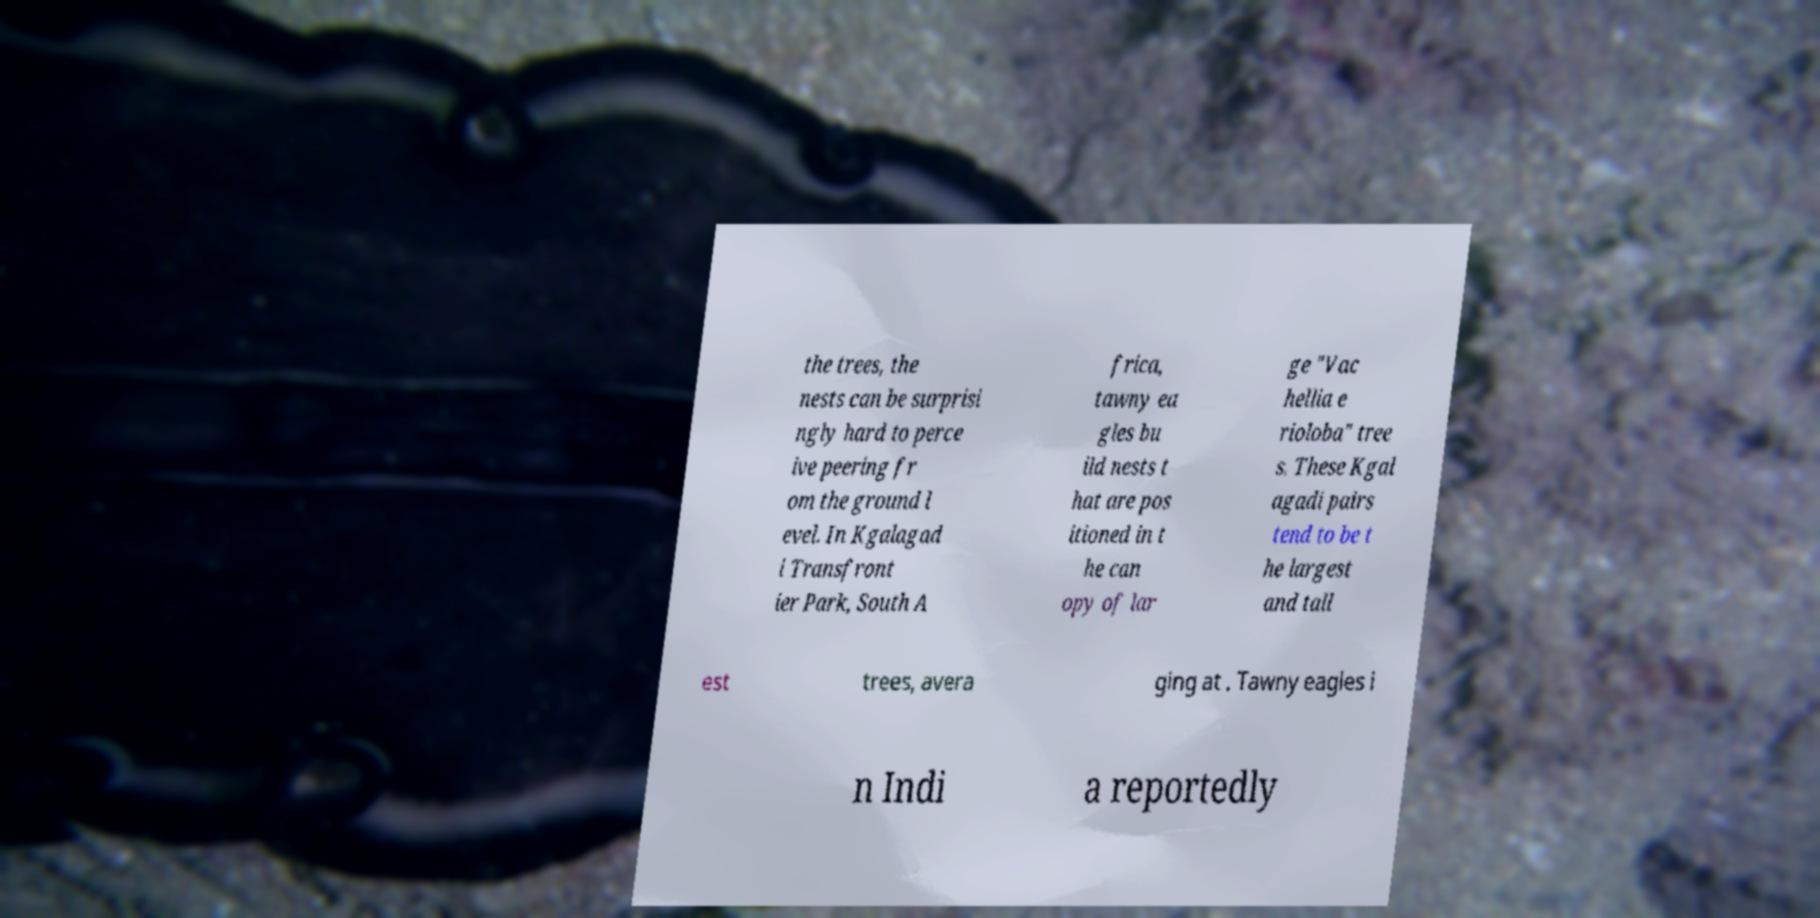Can you read and provide the text displayed in the image?This photo seems to have some interesting text. Can you extract and type it out for me? the trees, the nests can be surprisi ngly hard to perce ive peering fr om the ground l evel. In Kgalagad i Transfront ier Park, South A frica, tawny ea gles bu ild nests t hat are pos itioned in t he can opy of lar ge "Vac hellia e rioloba" tree s. These Kgal agadi pairs tend to be t he largest and tall est trees, avera ging at . Tawny eagles i n Indi a reportedly 